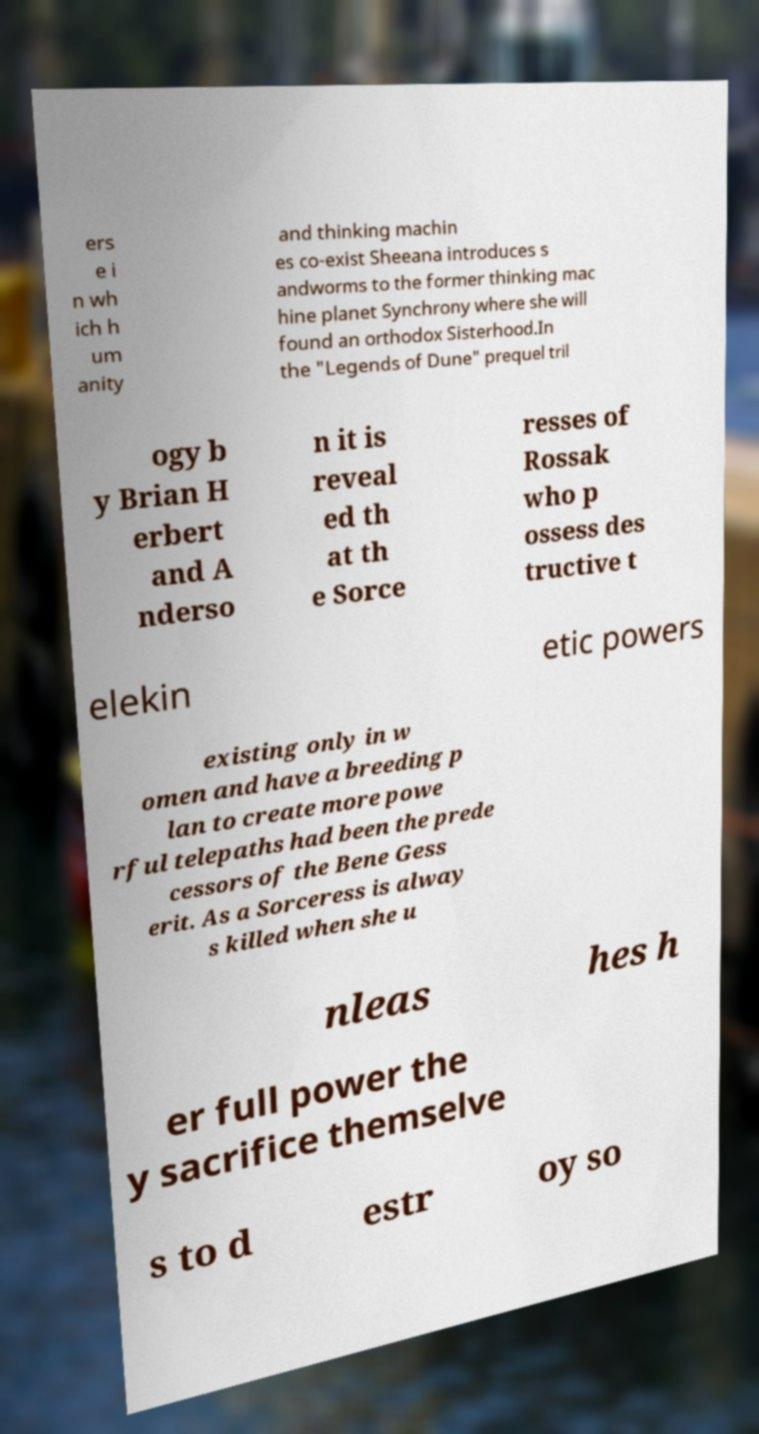Can you read and provide the text displayed in the image?This photo seems to have some interesting text. Can you extract and type it out for me? ers e i n wh ich h um anity and thinking machin es co-exist Sheeana introduces s andworms to the former thinking mac hine planet Synchrony where she will found an orthodox Sisterhood.In the "Legends of Dune" prequel tril ogy b y Brian H erbert and A nderso n it is reveal ed th at th e Sorce resses of Rossak who p ossess des tructive t elekin etic powers existing only in w omen and have a breeding p lan to create more powe rful telepaths had been the prede cessors of the Bene Gess erit. As a Sorceress is alway s killed when she u nleas hes h er full power the y sacrifice themselve s to d estr oy so 